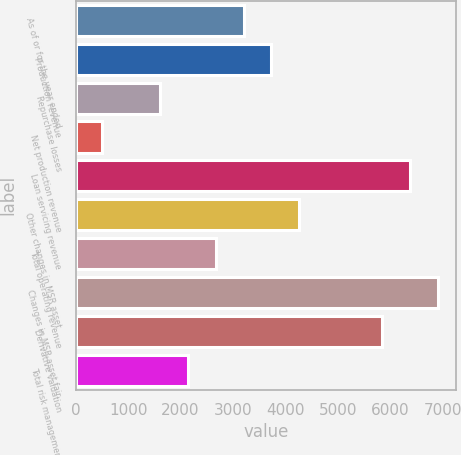<chart> <loc_0><loc_0><loc_500><loc_500><bar_chart><fcel>As of or for the year ended<fcel>Production revenue<fcel>Repurchase losses<fcel>Net production revenue<fcel>Loan servicing revenue<fcel>Other changes in MSR asset<fcel>Total operating revenue<fcel>Changes in MSR asset fair<fcel>Derivative valuation<fcel>Total risk management<nl><fcel>3202.3<fcel>3732.4<fcel>1612<fcel>503<fcel>6382.9<fcel>4262.5<fcel>2672.2<fcel>6913<fcel>5852.8<fcel>2142.1<nl></chart> 